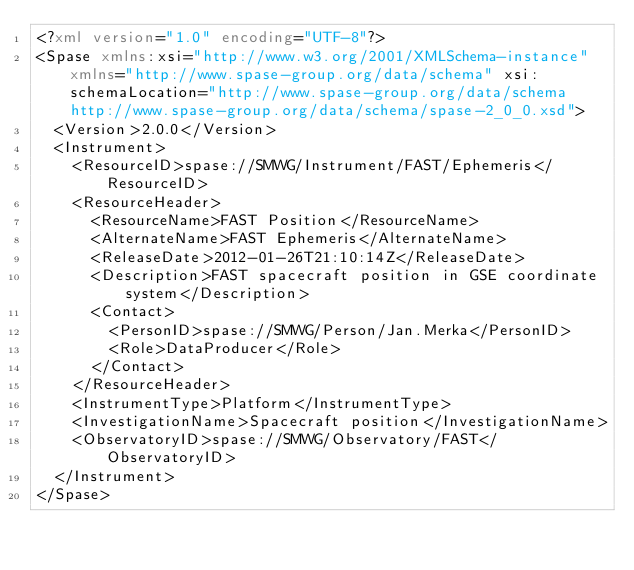Convert code to text. <code><loc_0><loc_0><loc_500><loc_500><_XML_><?xml version="1.0" encoding="UTF-8"?>
<Spase xmlns:xsi="http://www.w3.org/2001/XMLSchema-instance" xmlns="http://www.spase-group.org/data/schema" xsi:schemaLocation="http://www.spase-group.org/data/schema http://www.spase-group.org/data/schema/spase-2_0_0.xsd">
  <Version>2.0.0</Version>
  <Instrument>
    <ResourceID>spase://SMWG/Instrument/FAST/Ephemeris</ResourceID>
    <ResourceHeader>
      <ResourceName>FAST Position</ResourceName>
      <AlternateName>FAST Ephemeris</AlternateName>
      <ReleaseDate>2012-01-26T21:10:14Z</ReleaseDate>
      <Description>FAST spacecraft position in GSE coordinate system</Description>
      <Contact>
        <PersonID>spase://SMWG/Person/Jan.Merka</PersonID>
        <Role>DataProducer</Role>
      </Contact>
    </ResourceHeader>
    <InstrumentType>Platform</InstrumentType>
    <InvestigationName>Spacecraft position</InvestigationName>
    <ObservatoryID>spase://SMWG/Observatory/FAST</ObservatoryID>
  </Instrument>
</Spase>
</code> 